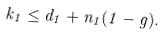Convert formula to latex. <formula><loc_0><loc_0><loc_500><loc_500>k _ { 1 } \leq d _ { 1 } + n _ { 1 } ( 1 - g ) .</formula> 